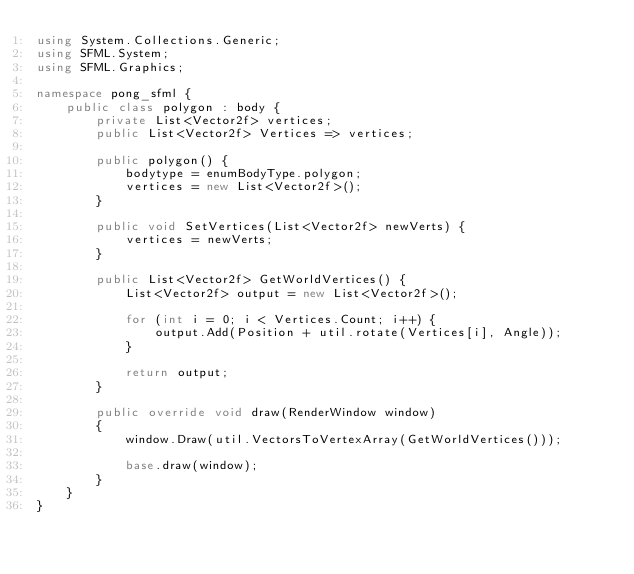<code> <loc_0><loc_0><loc_500><loc_500><_C#_>using System.Collections.Generic;
using SFML.System;
using SFML.Graphics;

namespace pong_sfml {
    public class polygon : body {
        private List<Vector2f> vertices;
        public List<Vector2f> Vertices => vertices;

        public polygon() {
            bodytype = enumBodyType.polygon;
            vertices = new List<Vector2f>();
        }

        public void SetVertices(List<Vector2f> newVerts) {
            vertices = newVerts;
        }

        public List<Vector2f> GetWorldVertices() {
            List<Vector2f> output = new List<Vector2f>();

            for (int i = 0; i < Vertices.Count; i++) {
                output.Add(Position + util.rotate(Vertices[i], Angle));
            }

            return output;
        }

        public override void draw(RenderWindow window)
        {
            window.Draw(util.VectorsToVertexArray(GetWorldVertices()));

            base.draw(window);
        }
    }
}</code> 